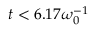Convert formula to latex. <formula><loc_0><loc_0><loc_500><loc_500>t < 6 . 1 7 \omega _ { 0 } ^ { - 1 }</formula> 